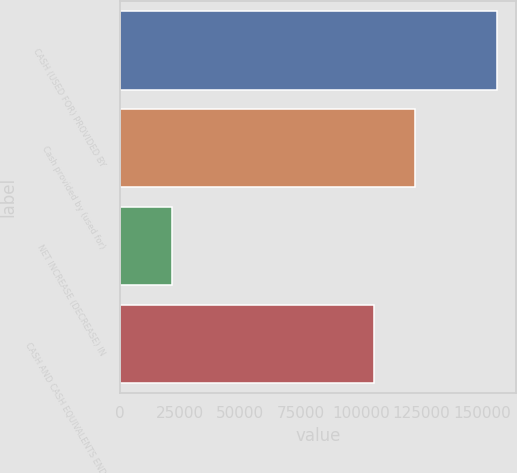Convert chart to OTSL. <chart><loc_0><loc_0><loc_500><loc_500><bar_chart><fcel>CASH (USED FOR) PROVIDED BY<fcel>Cash provided by (used for)<fcel>NET INCREASE (DECREASE) IN<fcel>CASH AND CASH EQUIVALENTS END<nl><fcel>156386<fcel>122203<fcel>21827<fcel>105465<nl></chart> 